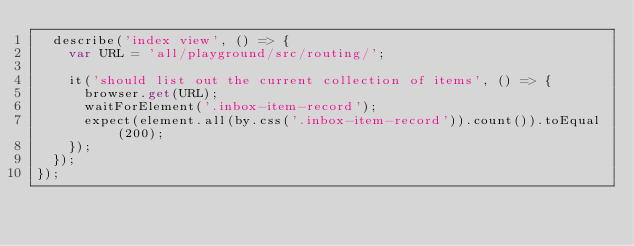<code> <loc_0><loc_0><loc_500><loc_500><_TypeScript_>  describe('index view', () => {
    var URL = 'all/playground/src/routing/';

    it('should list out the current collection of items', () => {
      browser.get(URL);
      waitForElement('.inbox-item-record');
      expect(element.all(by.css('.inbox-item-record')).count()).toEqual(200);
    });
  });
});
</code> 